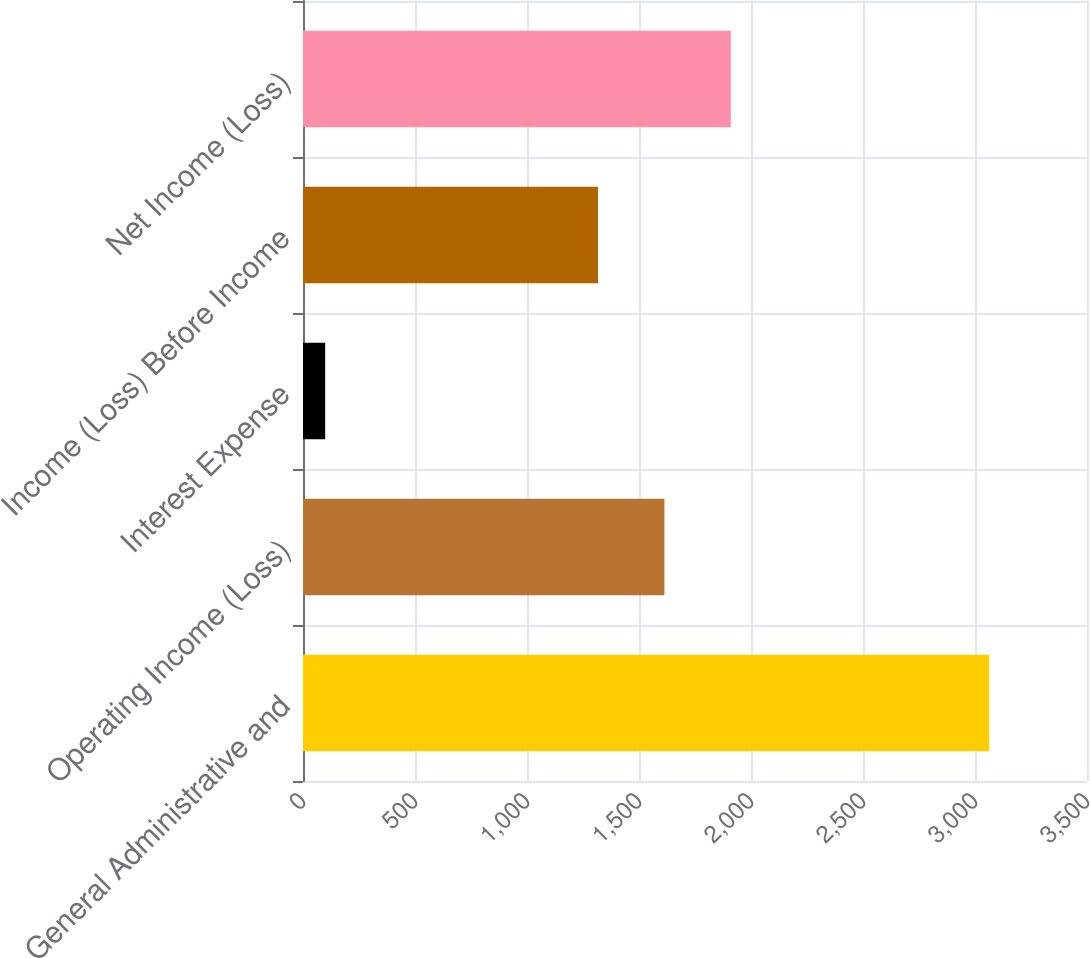Convert chart to OTSL. <chart><loc_0><loc_0><loc_500><loc_500><bar_chart><fcel>General Administrative and<fcel>Operating Income (Loss)<fcel>Interest Expense<fcel>Income (Loss) Before Income<fcel>Net Income (Loss)<nl><fcel>3063<fcel>1613.4<fcel>99<fcel>1317<fcel>1909.8<nl></chart> 